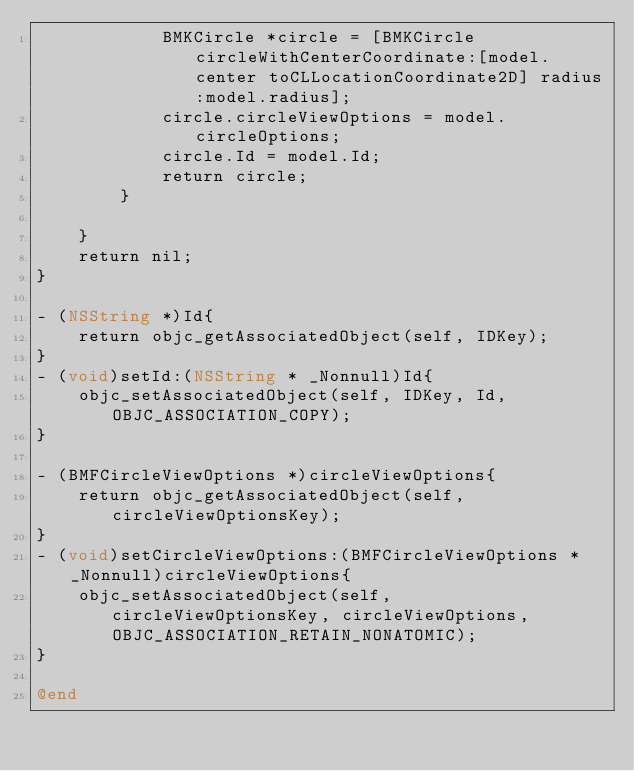Convert code to text. <code><loc_0><loc_0><loc_500><loc_500><_ObjectiveC_>            BMKCircle *circle = [BMKCircle circleWithCenterCoordinate:[model.center toCLLocationCoordinate2D] radius:model.radius];
            circle.circleViewOptions = model.circleOptions;
            circle.Id = model.Id;
            return circle;
        }
      
    }
    return nil;
}

- (NSString *)Id{
    return objc_getAssociatedObject(self, IDKey);
}
- (void)setId:(NSString * _Nonnull)Id{
    objc_setAssociatedObject(self, IDKey, Id, OBJC_ASSOCIATION_COPY);
}

- (BMFCircleViewOptions *)circleViewOptions{
    return objc_getAssociatedObject(self, circleViewOptionsKey);
}
- (void)setCircleViewOptions:(BMFCircleViewOptions * _Nonnull)circleViewOptions{
    objc_setAssociatedObject(self, circleViewOptionsKey, circleViewOptions, OBJC_ASSOCIATION_RETAIN_NONATOMIC);
}

@end
</code> 